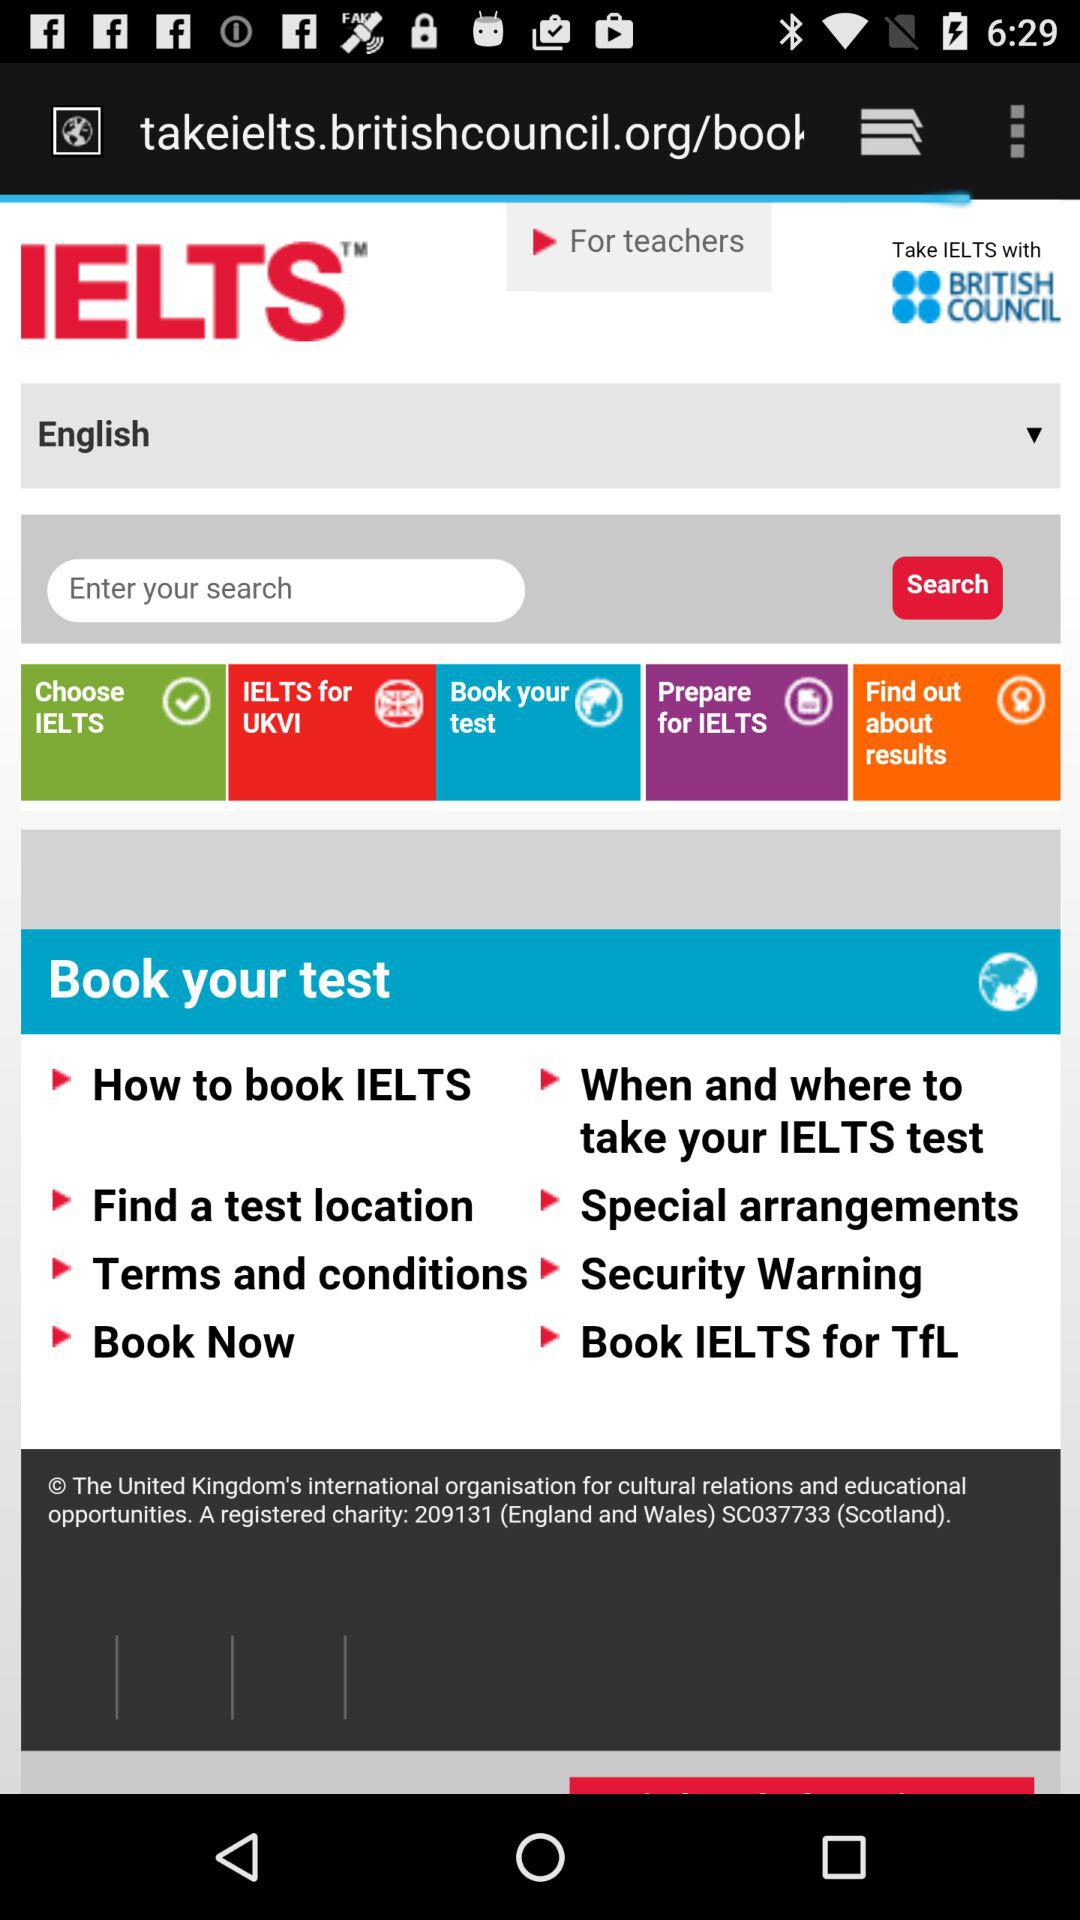Which language is selected? The selected language is English. 